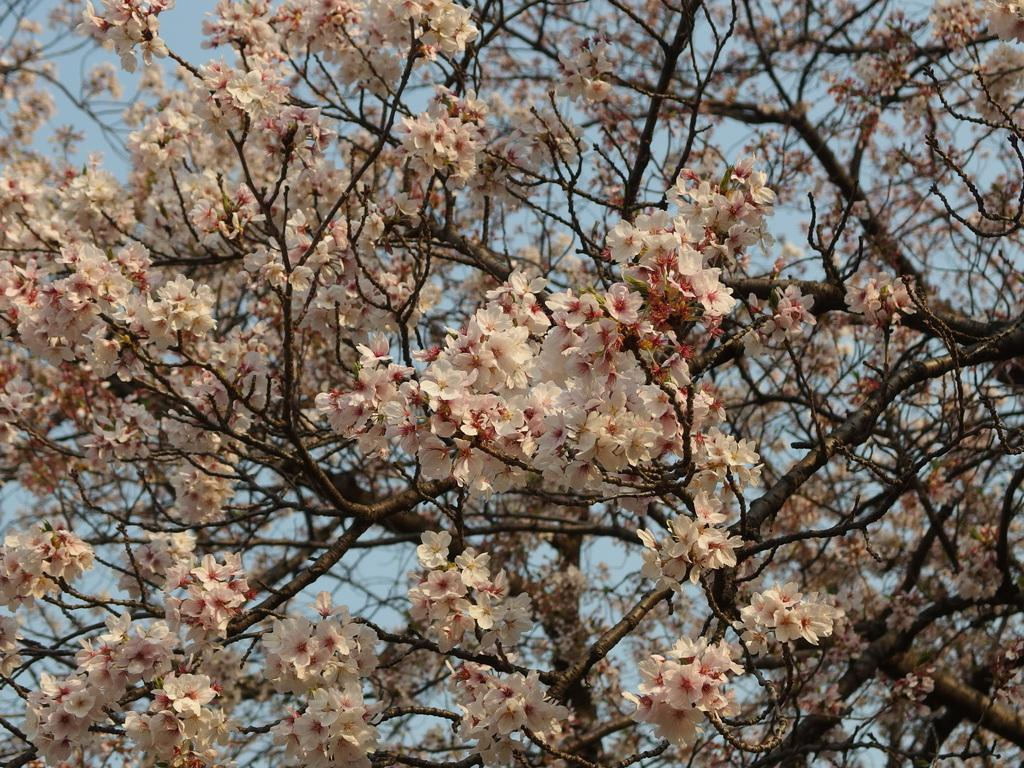What type of plant can be seen in the image? There is a tree in the image. What color are the flowers on the tree? White-colored flowers are present on the tree. What type of shoe is hanging from the tree in the image? There is no shoe present in the image; it only features a tree with white-colored flowers. 